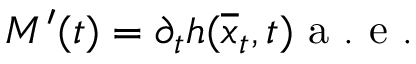Convert formula to latex. <formula><loc_0><loc_0><loc_500><loc_500>M ^ { \prime } ( t ) = \partial _ { t } h ( \overline { x } _ { t } , t ) a . e .</formula> 